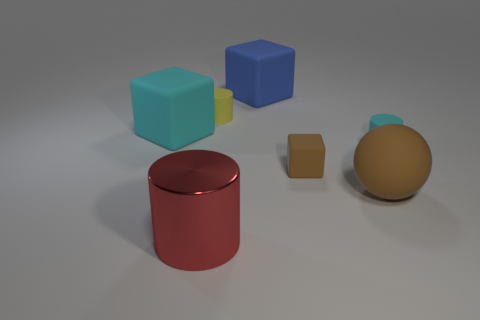What is the shape of the matte thing that is the same color as the ball?
Your answer should be compact. Cube. What material is the brown cube?
Give a very brief answer. Rubber. What size is the rubber cube that is in front of the large cyan matte thing?
Your response must be concise. Small. What number of other objects have the same shape as the tiny brown rubber thing?
Offer a very short reply. 2. There is a tiny brown thing that is made of the same material as the big brown object; what is its shape?
Give a very brief answer. Cube. How many red objects are either metallic cylinders or tiny shiny things?
Ensure brevity in your answer.  1. Are there any big cylinders behind the red object?
Your answer should be compact. No. There is a large matte thing that is on the left side of the big red metal object; is its shape the same as the cyan matte thing on the right side of the tiny yellow rubber cylinder?
Provide a succinct answer. No. There is a yellow object that is the same shape as the red shiny thing; what is its material?
Ensure brevity in your answer.  Rubber. How many spheres are either small cyan matte things or large cyan metallic objects?
Ensure brevity in your answer.  0. 